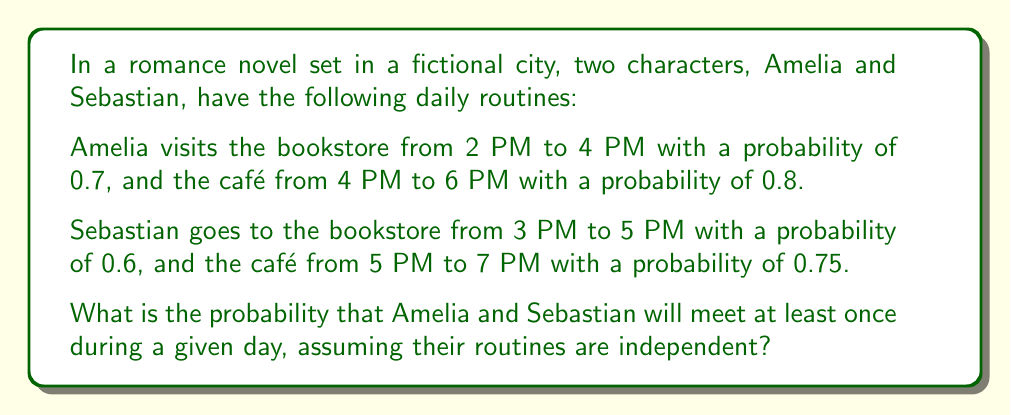Give your solution to this math problem. Let's approach this problem step-by-step:

1) First, we need to calculate the probability of Amelia and Sebastian meeting at each location:

   a) At the bookstore:
      They can meet between 3 PM and 4 PM.
      $P(\text{meet at bookstore}) = 0.7 \times 0.6 = 0.42$

   b) At the café:
      They can meet between 5 PM and 6 PM.
      $P(\text{meet at café}) = 0.8 \times 0.75 = 0.6$

2) Now, we need to find the probability of them meeting at least once. It's easier to calculate the probability of them not meeting and then subtract from 1.

3) The probability of not meeting:
   $P(\text{not meeting}) = P(\text{not meeting at bookstore AND not meeting at café})$

4) Since the events are independent:
   $P(\text{not meeting}) = (1 - 0.42) \times (1 - 0.6) = 0.58 \times 0.4 = 0.232$

5) Therefore, the probability of meeting at least once is:
   $P(\text{meeting at least once}) = 1 - P(\text{not meeting}) = 1 - 0.232 = 0.768$
Answer: The probability that Amelia and Sebastian will meet at least once during a given day is 0.768 or 76.8%. 